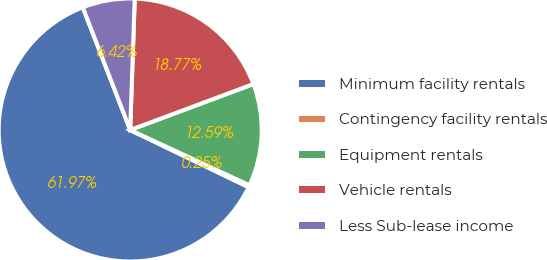<chart> <loc_0><loc_0><loc_500><loc_500><pie_chart><fcel>Minimum facility rentals<fcel>Contingency facility rentals<fcel>Equipment rentals<fcel>Vehicle rentals<fcel>Less Sub-lease income<nl><fcel>61.97%<fcel>0.25%<fcel>12.59%<fcel>18.77%<fcel>6.42%<nl></chart> 